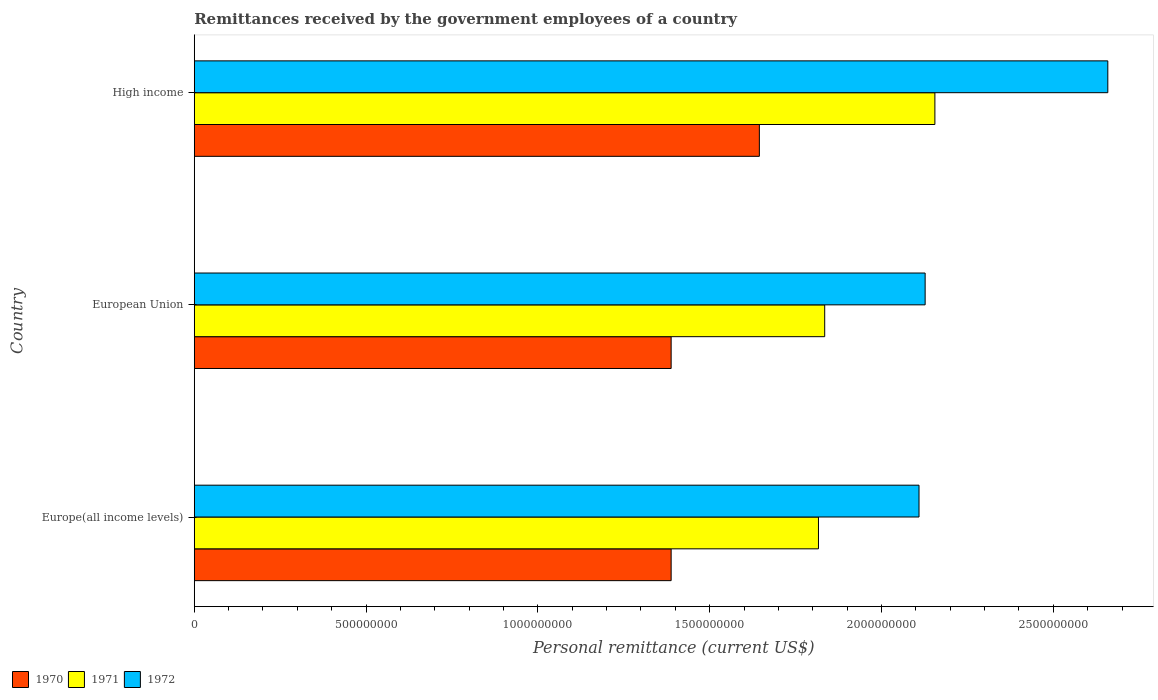How many different coloured bars are there?
Provide a short and direct response. 3. Are the number of bars per tick equal to the number of legend labels?
Make the answer very short. Yes. How many bars are there on the 2nd tick from the top?
Ensure brevity in your answer.  3. How many bars are there on the 1st tick from the bottom?
Provide a short and direct response. 3. What is the label of the 3rd group of bars from the top?
Make the answer very short. Europe(all income levels). What is the remittances received by the government employees in 1972 in High income?
Provide a short and direct response. 2.66e+09. Across all countries, what is the maximum remittances received by the government employees in 1970?
Provide a succinct answer. 1.64e+09. Across all countries, what is the minimum remittances received by the government employees in 1971?
Ensure brevity in your answer.  1.82e+09. In which country was the remittances received by the government employees in 1970 maximum?
Your answer should be compact. High income. In which country was the remittances received by the government employees in 1970 minimum?
Make the answer very short. Europe(all income levels). What is the total remittances received by the government employees in 1971 in the graph?
Make the answer very short. 5.81e+09. What is the difference between the remittances received by the government employees in 1970 in Europe(all income levels) and that in European Union?
Keep it short and to the point. 0. What is the difference between the remittances received by the government employees in 1970 in High income and the remittances received by the government employees in 1971 in Europe(all income levels)?
Your response must be concise. -1.72e+08. What is the average remittances received by the government employees in 1972 per country?
Your answer should be very brief. 2.30e+09. What is the difference between the remittances received by the government employees in 1972 and remittances received by the government employees in 1971 in High income?
Offer a terse response. 5.03e+08. In how many countries, is the remittances received by the government employees in 1971 greater than 800000000 US$?
Make the answer very short. 3. Is the remittances received by the government employees in 1970 in Europe(all income levels) less than that in European Union?
Keep it short and to the point. No. Is the difference between the remittances received by the government employees in 1972 in Europe(all income levels) and European Union greater than the difference between the remittances received by the government employees in 1971 in Europe(all income levels) and European Union?
Your response must be concise. Yes. What is the difference between the highest and the second highest remittances received by the government employees in 1970?
Your answer should be very brief. 2.57e+08. What is the difference between the highest and the lowest remittances received by the government employees in 1970?
Your response must be concise. 2.57e+08. Is the sum of the remittances received by the government employees in 1970 in European Union and High income greater than the maximum remittances received by the government employees in 1972 across all countries?
Provide a succinct answer. Yes. What does the 3rd bar from the top in High income represents?
Make the answer very short. 1970. What does the 3rd bar from the bottom in European Union represents?
Your response must be concise. 1972. Is it the case that in every country, the sum of the remittances received by the government employees in 1971 and remittances received by the government employees in 1972 is greater than the remittances received by the government employees in 1970?
Your answer should be very brief. Yes. Are all the bars in the graph horizontal?
Provide a succinct answer. Yes. How many countries are there in the graph?
Provide a succinct answer. 3. What is the difference between two consecutive major ticks on the X-axis?
Give a very brief answer. 5.00e+08. Are the values on the major ticks of X-axis written in scientific E-notation?
Keep it short and to the point. No. How many legend labels are there?
Give a very brief answer. 3. How are the legend labels stacked?
Your answer should be very brief. Horizontal. What is the title of the graph?
Ensure brevity in your answer.  Remittances received by the government employees of a country. Does "1997" appear as one of the legend labels in the graph?
Offer a very short reply. No. What is the label or title of the X-axis?
Your response must be concise. Personal remittance (current US$). What is the label or title of the Y-axis?
Give a very brief answer. Country. What is the Personal remittance (current US$) of 1970 in Europe(all income levels)?
Your response must be concise. 1.39e+09. What is the Personal remittance (current US$) in 1971 in Europe(all income levels)?
Your response must be concise. 1.82e+09. What is the Personal remittance (current US$) in 1972 in Europe(all income levels)?
Your answer should be compact. 2.11e+09. What is the Personal remittance (current US$) of 1970 in European Union?
Your response must be concise. 1.39e+09. What is the Personal remittance (current US$) of 1971 in European Union?
Provide a succinct answer. 1.83e+09. What is the Personal remittance (current US$) in 1972 in European Union?
Ensure brevity in your answer.  2.13e+09. What is the Personal remittance (current US$) in 1970 in High income?
Your answer should be very brief. 1.64e+09. What is the Personal remittance (current US$) in 1971 in High income?
Give a very brief answer. 2.16e+09. What is the Personal remittance (current US$) of 1972 in High income?
Your response must be concise. 2.66e+09. Across all countries, what is the maximum Personal remittance (current US$) in 1970?
Offer a terse response. 1.64e+09. Across all countries, what is the maximum Personal remittance (current US$) of 1971?
Keep it short and to the point. 2.16e+09. Across all countries, what is the maximum Personal remittance (current US$) of 1972?
Your answer should be very brief. 2.66e+09. Across all countries, what is the minimum Personal remittance (current US$) in 1970?
Offer a terse response. 1.39e+09. Across all countries, what is the minimum Personal remittance (current US$) in 1971?
Your answer should be very brief. 1.82e+09. Across all countries, what is the minimum Personal remittance (current US$) in 1972?
Make the answer very short. 2.11e+09. What is the total Personal remittance (current US$) in 1970 in the graph?
Offer a very short reply. 4.42e+09. What is the total Personal remittance (current US$) of 1971 in the graph?
Make the answer very short. 5.81e+09. What is the total Personal remittance (current US$) of 1972 in the graph?
Give a very brief answer. 6.89e+09. What is the difference between the Personal remittance (current US$) of 1970 in Europe(all income levels) and that in European Union?
Provide a succinct answer. 0. What is the difference between the Personal remittance (current US$) in 1971 in Europe(all income levels) and that in European Union?
Offer a terse response. -1.82e+07. What is the difference between the Personal remittance (current US$) of 1972 in Europe(all income levels) and that in European Union?
Make the answer very short. -1.78e+07. What is the difference between the Personal remittance (current US$) in 1970 in Europe(all income levels) and that in High income?
Offer a very short reply. -2.57e+08. What is the difference between the Personal remittance (current US$) in 1971 in Europe(all income levels) and that in High income?
Provide a succinct answer. -3.39e+08. What is the difference between the Personal remittance (current US$) in 1972 in Europe(all income levels) and that in High income?
Make the answer very short. -5.49e+08. What is the difference between the Personal remittance (current US$) of 1970 in European Union and that in High income?
Offer a very short reply. -2.57e+08. What is the difference between the Personal remittance (current US$) of 1971 in European Union and that in High income?
Your response must be concise. -3.21e+08. What is the difference between the Personal remittance (current US$) of 1972 in European Union and that in High income?
Keep it short and to the point. -5.32e+08. What is the difference between the Personal remittance (current US$) in 1970 in Europe(all income levels) and the Personal remittance (current US$) in 1971 in European Union?
Your answer should be very brief. -4.47e+08. What is the difference between the Personal remittance (current US$) of 1970 in Europe(all income levels) and the Personal remittance (current US$) of 1972 in European Union?
Make the answer very short. -7.39e+08. What is the difference between the Personal remittance (current US$) in 1971 in Europe(all income levels) and the Personal remittance (current US$) in 1972 in European Union?
Give a very brief answer. -3.10e+08. What is the difference between the Personal remittance (current US$) of 1970 in Europe(all income levels) and the Personal remittance (current US$) of 1971 in High income?
Ensure brevity in your answer.  -7.68e+08. What is the difference between the Personal remittance (current US$) in 1970 in Europe(all income levels) and the Personal remittance (current US$) in 1972 in High income?
Offer a terse response. -1.27e+09. What is the difference between the Personal remittance (current US$) in 1971 in Europe(all income levels) and the Personal remittance (current US$) in 1972 in High income?
Give a very brief answer. -8.42e+08. What is the difference between the Personal remittance (current US$) in 1970 in European Union and the Personal remittance (current US$) in 1971 in High income?
Keep it short and to the point. -7.68e+08. What is the difference between the Personal remittance (current US$) of 1970 in European Union and the Personal remittance (current US$) of 1972 in High income?
Provide a succinct answer. -1.27e+09. What is the difference between the Personal remittance (current US$) of 1971 in European Union and the Personal remittance (current US$) of 1972 in High income?
Your answer should be compact. -8.24e+08. What is the average Personal remittance (current US$) of 1970 per country?
Your answer should be compact. 1.47e+09. What is the average Personal remittance (current US$) of 1971 per country?
Ensure brevity in your answer.  1.94e+09. What is the average Personal remittance (current US$) of 1972 per country?
Offer a very short reply. 2.30e+09. What is the difference between the Personal remittance (current US$) of 1970 and Personal remittance (current US$) of 1971 in Europe(all income levels)?
Provide a succinct answer. -4.29e+08. What is the difference between the Personal remittance (current US$) in 1970 and Personal remittance (current US$) in 1972 in Europe(all income levels)?
Your answer should be very brief. -7.21e+08. What is the difference between the Personal remittance (current US$) of 1971 and Personal remittance (current US$) of 1972 in Europe(all income levels)?
Make the answer very short. -2.93e+08. What is the difference between the Personal remittance (current US$) in 1970 and Personal remittance (current US$) in 1971 in European Union?
Your answer should be compact. -4.47e+08. What is the difference between the Personal remittance (current US$) in 1970 and Personal remittance (current US$) in 1972 in European Union?
Your answer should be compact. -7.39e+08. What is the difference between the Personal remittance (current US$) of 1971 and Personal remittance (current US$) of 1972 in European Union?
Provide a succinct answer. -2.92e+08. What is the difference between the Personal remittance (current US$) of 1970 and Personal remittance (current US$) of 1971 in High income?
Keep it short and to the point. -5.11e+08. What is the difference between the Personal remittance (current US$) of 1970 and Personal remittance (current US$) of 1972 in High income?
Provide a succinct answer. -1.01e+09. What is the difference between the Personal remittance (current US$) in 1971 and Personal remittance (current US$) in 1972 in High income?
Ensure brevity in your answer.  -5.03e+08. What is the ratio of the Personal remittance (current US$) of 1970 in Europe(all income levels) to that in European Union?
Keep it short and to the point. 1. What is the ratio of the Personal remittance (current US$) in 1971 in Europe(all income levels) to that in European Union?
Ensure brevity in your answer.  0.99. What is the ratio of the Personal remittance (current US$) in 1972 in Europe(all income levels) to that in European Union?
Offer a very short reply. 0.99. What is the ratio of the Personal remittance (current US$) of 1970 in Europe(all income levels) to that in High income?
Provide a short and direct response. 0.84. What is the ratio of the Personal remittance (current US$) in 1971 in Europe(all income levels) to that in High income?
Provide a short and direct response. 0.84. What is the ratio of the Personal remittance (current US$) in 1972 in Europe(all income levels) to that in High income?
Offer a very short reply. 0.79. What is the ratio of the Personal remittance (current US$) of 1970 in European Union to that in High income?
Ensure brevity in your answer.  0.84. What is the ratio of the Personal remittance (current US$) in 1971 in European Union to that in High income?
Ensure brevity in your answer.  0.85. What is the ratio of the Personal remittance (current US$) of 1972 in European Union to that in High income?
Your answer should be very brief. 0.8. What is the difference between the highest and the second highest Personal remittance (current US$) in 1970?
Offer a terse response. 2.57e+08. What is the difference between the highest and the second highest Personal remittance (current US$) in 1971?
Your answer should be very brief. 3.21e+08. What is the difference between the highest and the second highest Personal remittance (current US$) in 1972?
Offer a terse response. 5.32e+08. What is the difference between the highest and the lowest Personal remittance (current US$) of 1970?
Provide a succinct answer. 2.57e+08. What is the difference between the highest and the lowest Personal remittance (current US$) in 1971?
Provide a succinct answer. 3.39e+08. What is the difference between the highest and the lowest Personal remittance (current US$) in 1972?
Provide a short and direct response. 5.49e+08. 